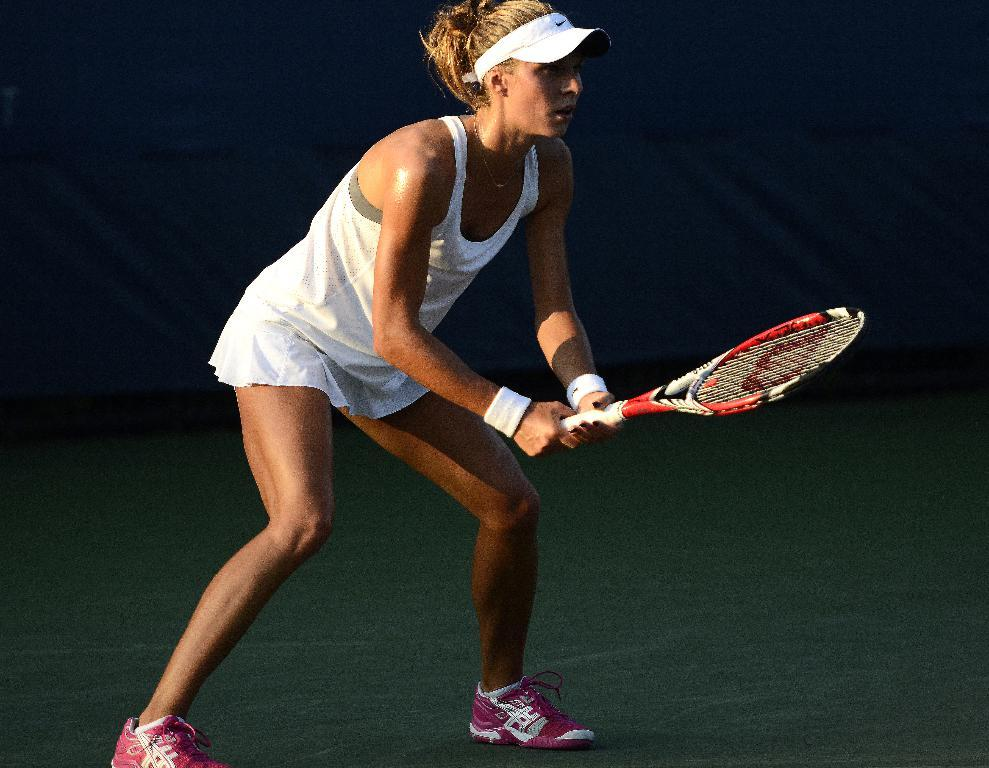What is the main subject of the image? The main subject of the image is a woman. What type of shoes is the woman wearing? The woman is wearing pink shoes. What headwear is the woman wearing? The woman is wearing a cap. What object is the woman holding in the image? The woman is holding a tennis racket. What is the woman standing on in the image? The woman is standing on the ground. What can be seen in the background of the image? There is a wall in the background of the image. What grade is the woman teaching in the image? There is no indication in the image that the woman is a teacher, nor is there any reference to a grade. 